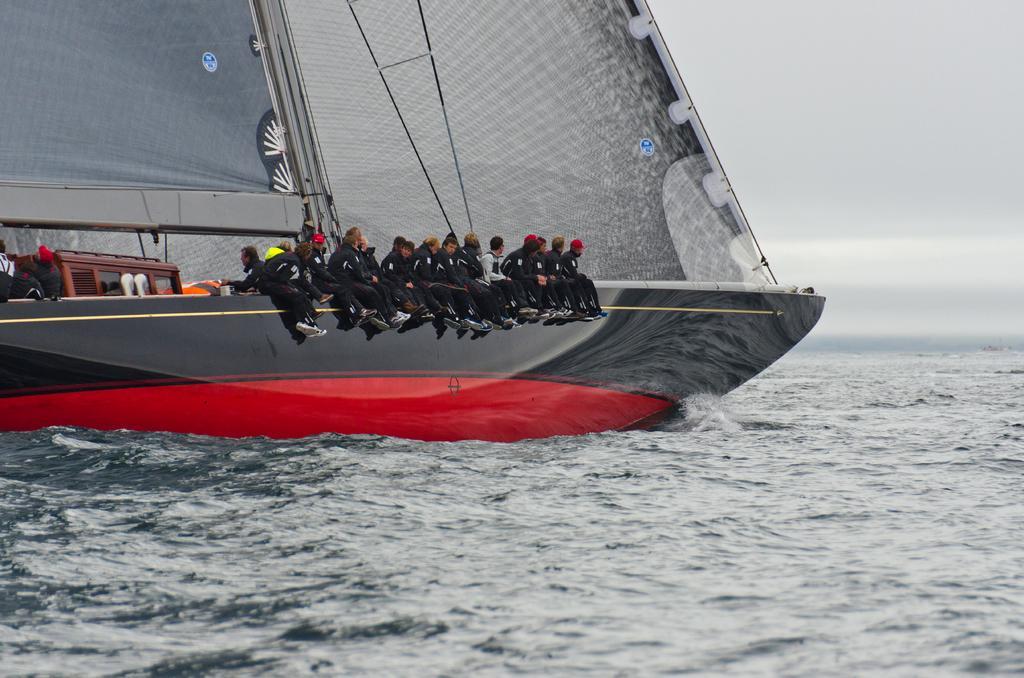Can you describe this image briefly? In this image, we can see a boat with a few people sailing. We can see the water and the sky. 